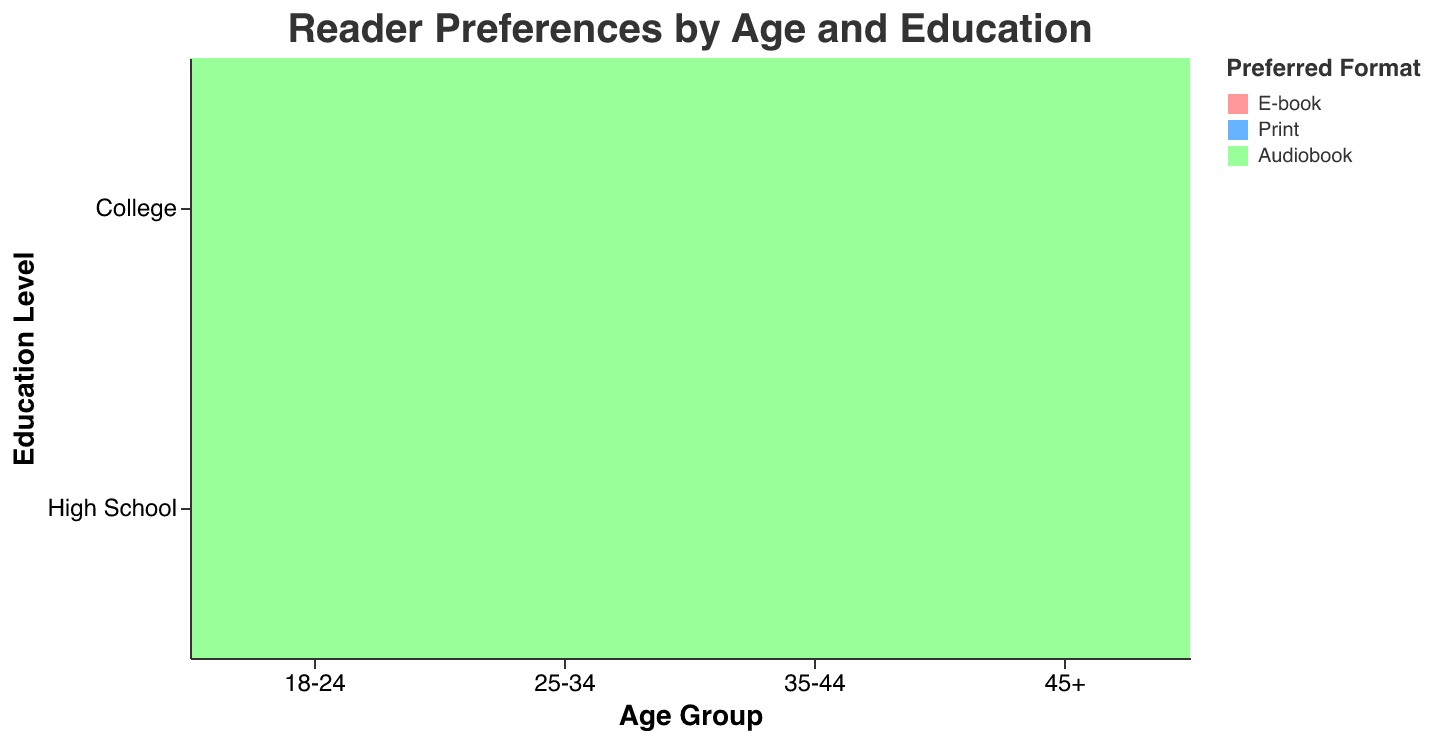What format is most preferred by 18-24 year-olds with a high school education? The plot shows that among 18-24 year-olds with a high school education, 'Print' books have the largest section, indicating the highest percentage.
Answer: Print What percentage of 25-34 year-olds with a college education prefer E-books? By referring to the plot, the percentage of 25-34 year-olds with a college education who prefer E-books is shown in the corresponding section.
Answer: 45% Which age group with a high school education has the highest preference for E-books? The plot shows different age groups with high school education and their preferences for book formats. The highest percentage for E-books in these groups is for the 25-34 age group.
Answer: 25-34 Across all age groups, which education level shows a higher preference for Print books? By comparing the size of the 'Print' sections across different age groups and education levels, high school education consistently shows larger sections for Print books.
Answer: High School Which preferred format remains consistently at 25% across several age and education categories? The plot indicates that Audiobooks have a 25% preference in multiple combinations of age groups and education levels.
Answer: Audiobooks What is the combined percentage of 18-24 year-olds with college education preferring Print and Audiobooks? From the plot, the percentages of 18-24 year-olds with a college education preferring Print and Audiobooks are 35% and 25%, respectively. Adding these gives 35% + 25% = 60%.
Answer: 60% Is there any age group where a specific preferred format reaches 60%? If so, identify the age group and format. The plot reveals that among 45+ year-olds with high school education, the preference for Print books reaches 60%.
Answer: 45+, Print Compare the preference for E-books between college-educated 18-24 year-olds and high school-educated 45+ year-olds. The plot shows that college-educated 18-24 year-olds prefer E-books at 40%, whereas high school-educated 45+ year-olds prefer E-books at 20%.
Answer: 40% vs 20% Which age group and education level combination has the lowest preference for Print books? By observing smaller sections of Print book preferences, 25-34 year-olds with college education have one of the smaller percentages at 30%.
Answer: 25-34, College Do college-educated individuals generally show a higher preference for E-books compared to those with high school education across all age groups? The plot indicates that across all age groups, college-educated individuals have larger sections for E-books compared to their high school counterparts.
Answer: Yes 